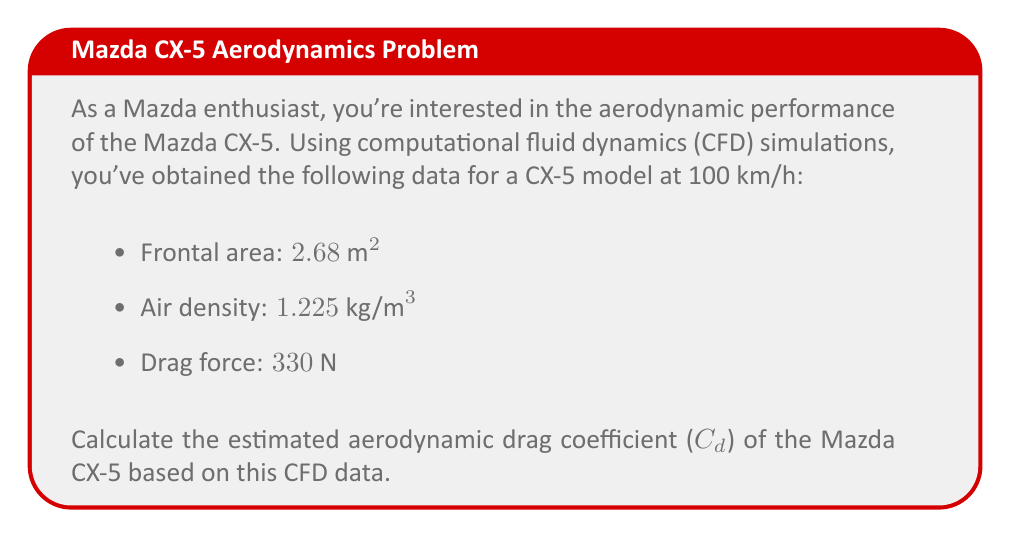Solve this math problem. To calculate the aerodynamic drag coefficient ($C_d$), we'll use the drag equation:

$$F_d = \frac{1}{2} \rho v^2 C_d A$$

Where:
- $F_d$ is the drag force (given as 330 N)
- $\rho$ is the air density (given as 1.225 kg/m³)
- $v$ is the velocity (100 km/h = 27.78 m/s)
- $A$ is the frontal area (given as 2.68 m²)
- $C_d$ is the drag coefficient (what we're solving for)

Let's solve the equation for $C_d$:

$$C_d = \frac{2F_d}{\rho v^2 A}$$

Now, let's substitute the values:

$$C_d = \frac{2 \cdot 330 \text{ N}}{1.225 \text{ kg/m}^3 \cdot (27.78 \text{ m/s})^2 \cdot 2.68 \text{ m}^2}$$

$$C_d = \frac{660}{1.225 \cdot 771.73 \cdot 2.68}$$

$$C_d = \frac{660}{2531.96}$$

$$C_d \approx 0.2607$$

Rounding to three decimal places, we get the estimated drag coefficient.
Answer: $C_d \approx 0.261$ 